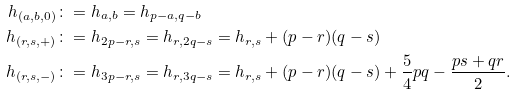Convert formula to latex. <formula><loc_0><loc_0><loc_500><loc_500>h _ { ( a , b , 0 ) } & \colon = h _ { a , b } = h _ { p - a , q - b } \\ h _ { ( r , s , + ) } & \colon = h _ { 2 p - r , s } = h _ { r , 2 q - s } = h _ { r , s } + ( p - r ) ( q - s ) \\ h _ { ( r , s , - ) } & \colon = h _ { 3 p - r , s } = h _ { r , 3 q - s } = h _ { r , s } + ( p - r ) ( q - s ) + \frac { 5 } { 4 } p q - \frac { p s + q r } { 2 } .</formula> 